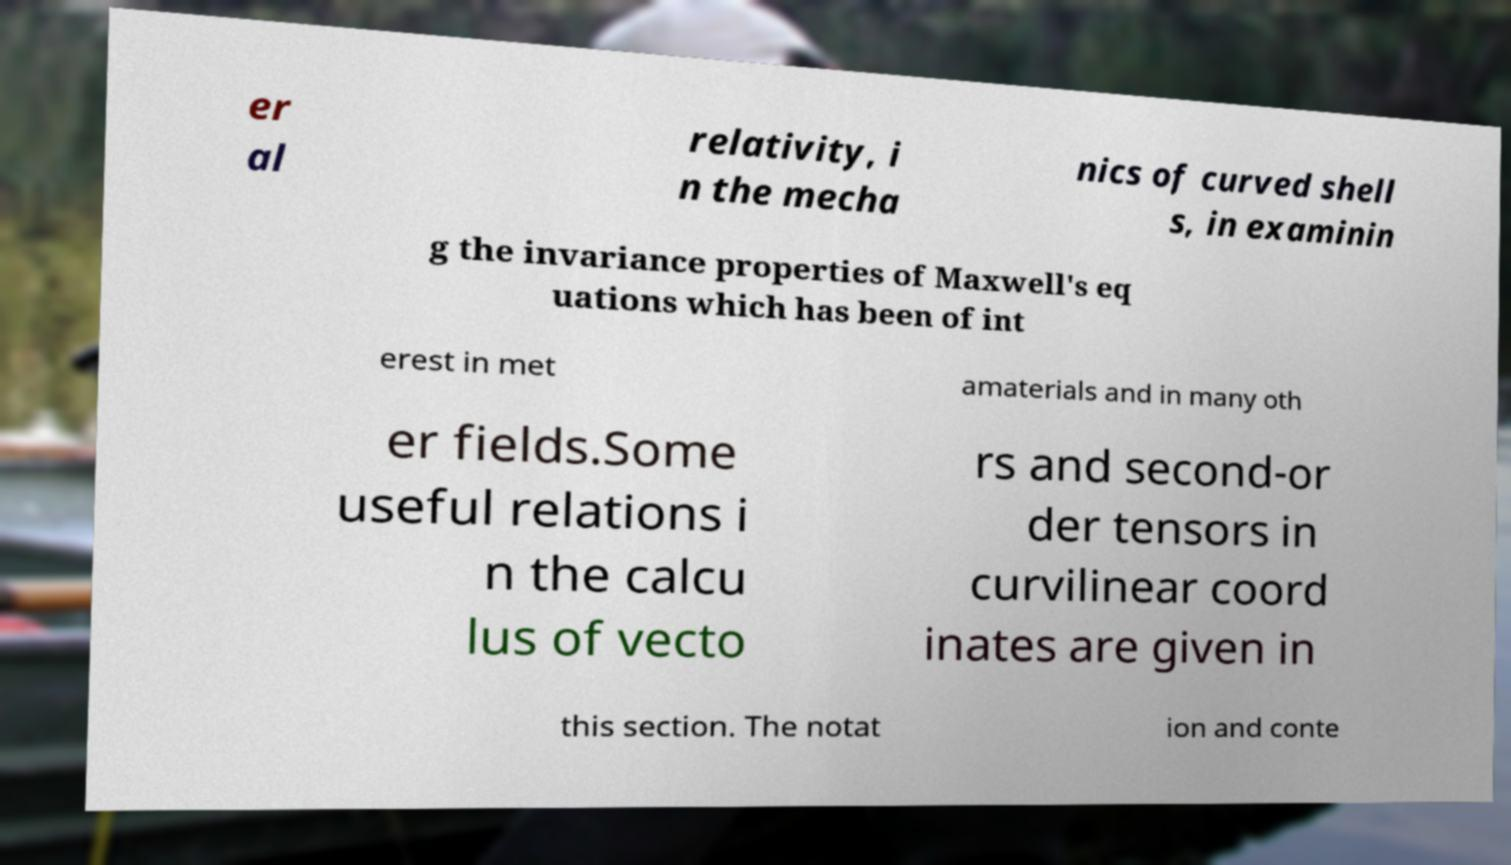Can you accurately transcribe the text from the provided image for me? er al relativity, i n the mecha nics of curved shell s, in examinin g the invariance properties of Maxwell's eq uations which has been of int erest in met amaterials and in many oth er fields.Some useful relations i n the calcu lus of vecto rs and second-or der tensors in curvilinear coord inates are given in this section. The notat ion and conte 